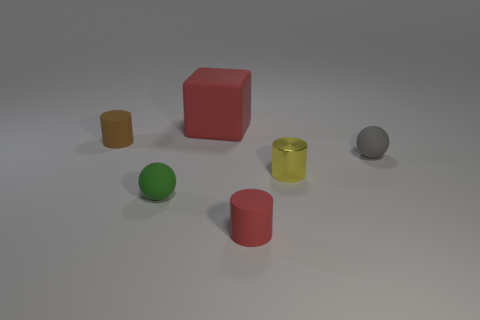Add 1 large yellow matte spheres. How many objects exist? 7 Subtract all spheres. How many objects are left? 4 Subtract 0 green cylinders. How many objects are left? 6 Subtract all small brown cylinders. Subtract all yellow metallic things. How many objects are left? 4 Add 2 tiny gray rubber balls. How many tiny gray rubber balls are left? 3 Add 1 matte cylinders. How many matte cylinders exist? 3 